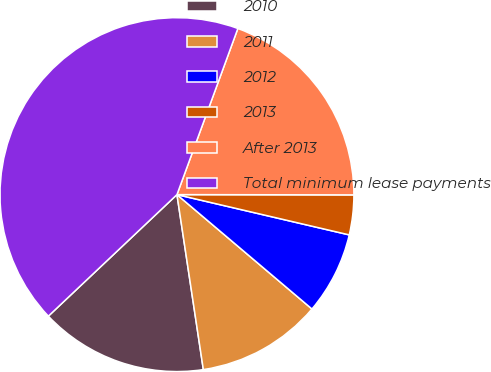<chart> <loc_0><loc_0><loc_500><loc_500><pie_chart><fcel>2010<fcel>2011<fcel>2012<fcel>2013<fcel>After 2013<fcel>Total minimum lease payments<nl><fcel>15.33%<fcel>11.43%<fcel>7.53%<fcel>3.63%<fcel>19.43%<fcel>42.64%<nl></chart> 